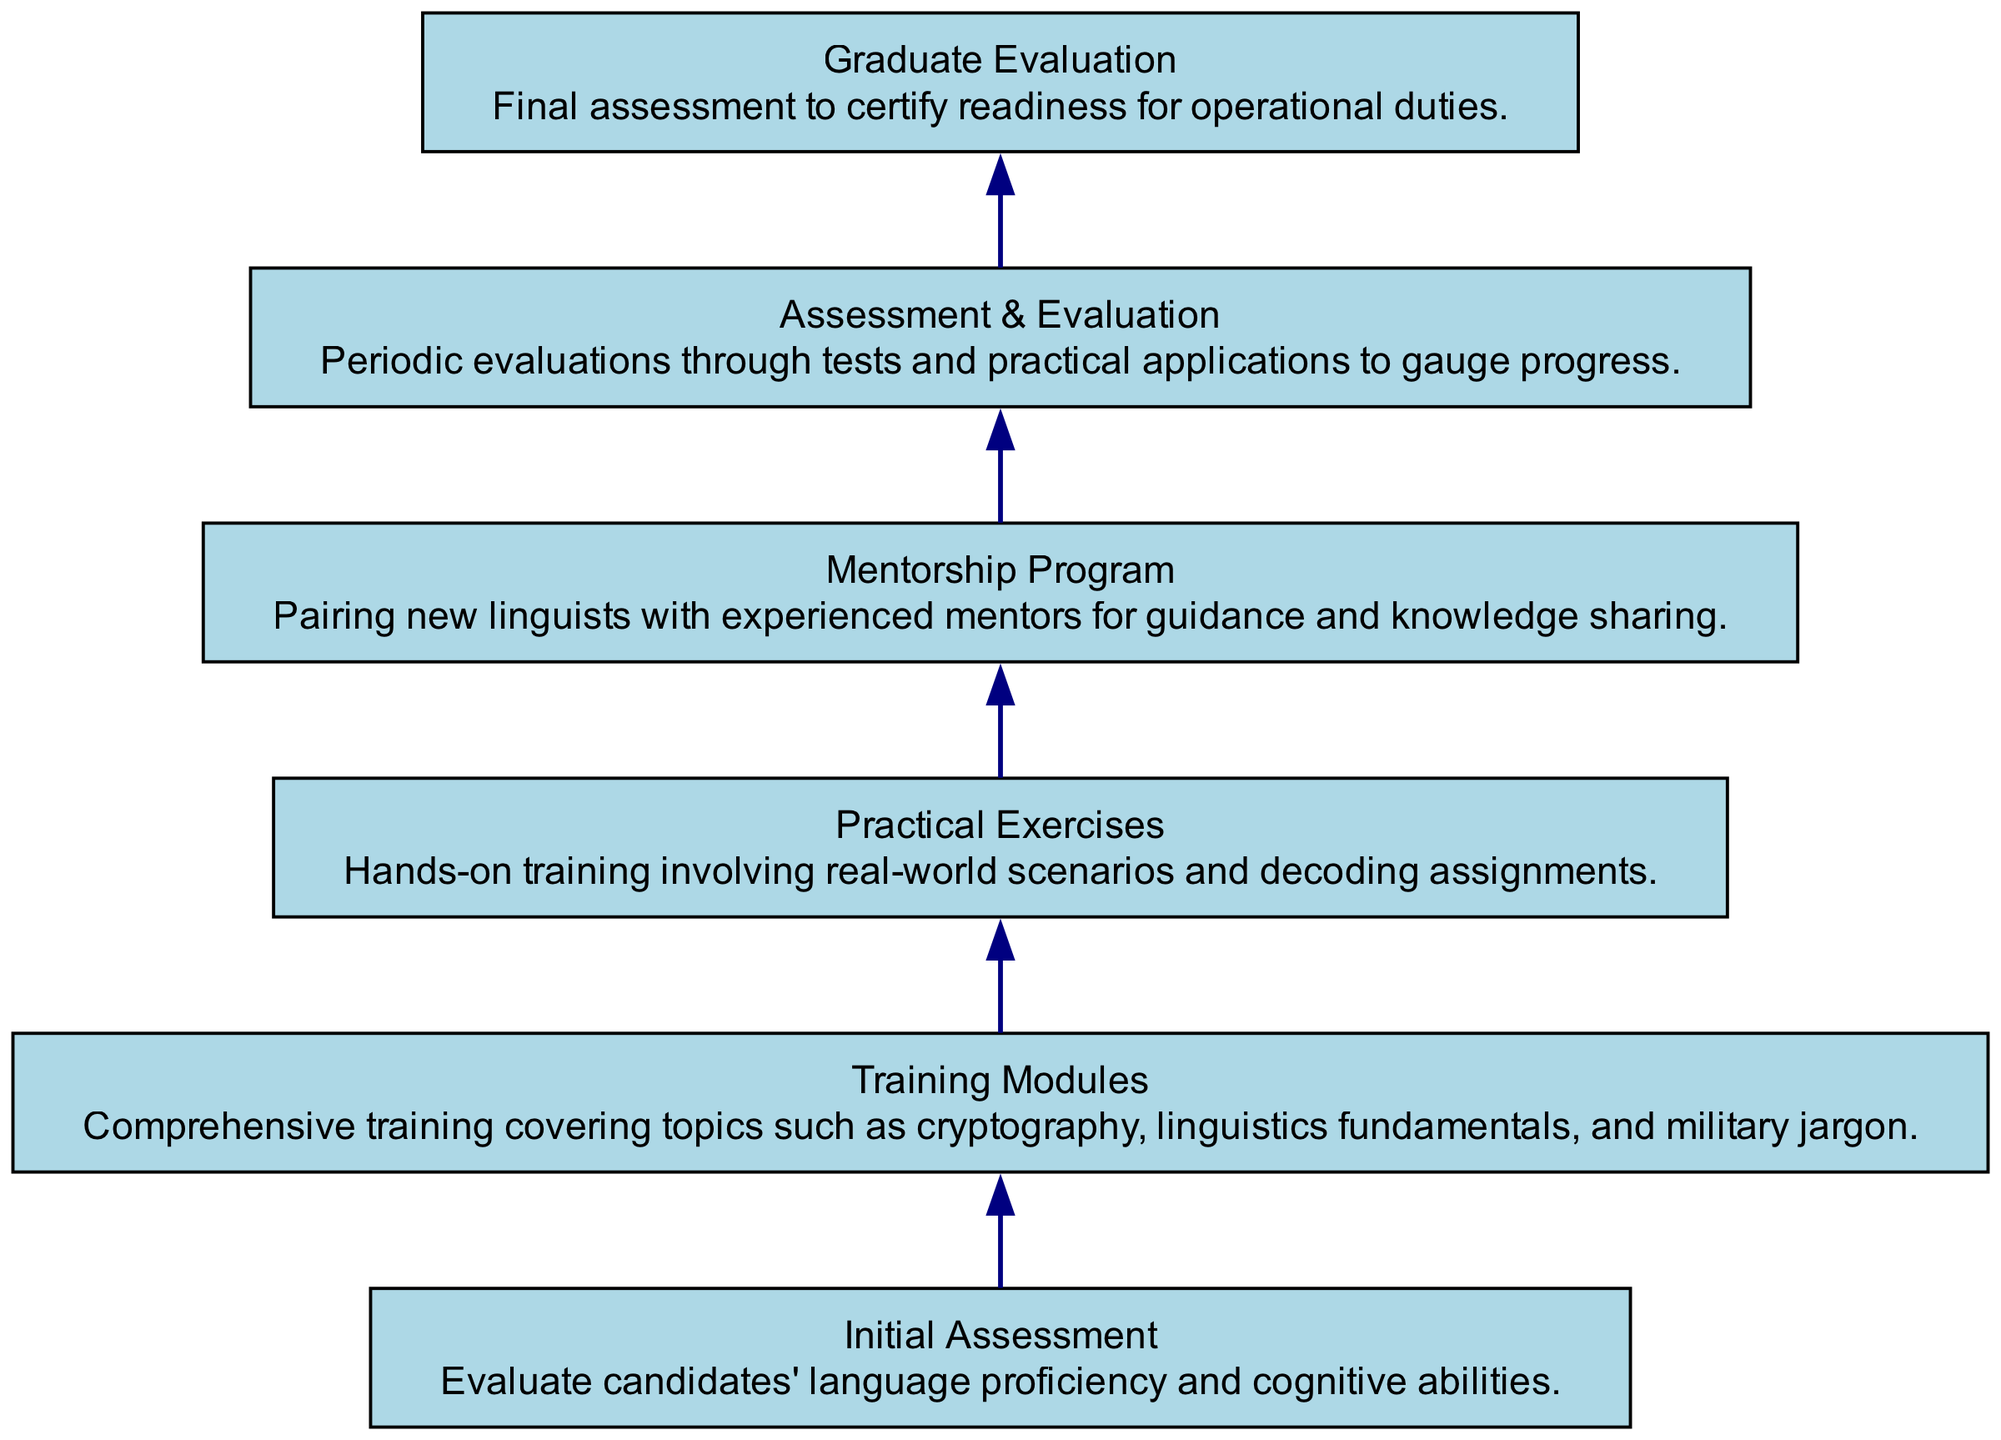What is the first step in the training workflow? The first step in the training workflow is the "Initial Assessment," which evaluates candidates' language proficiency and cognitive abilities.
Answer: Initial Assessment How many training modules are depicted in the diagram? The diagram contains one training module labeled "Training Modules," which covers various topics relevant to new linguists.
Answer: One What follows the "Practical Exercises" in the workflow? After "Practical Exercises," the next step is the "Mentorship Program," which pairs new linguists with experienced mentors.
Answer: Mentorship Program What is the final evaluation stage of the training process? The final evaluation stage is called "Graduate Evaluation," which certifies the readiness of new linguists for operational duties.
Answer: Graduate Evaluation How many edges connect the nodes in the diagram? The diagram has five edges connecting the various nodes, depicting the flow of the training sessions.
Answer: Five Which node is immediately before the "Assessment & Evaluation"? The node immediately preceding "Assessment & Evaluation" is "Mentorship Program," showing the workflow where mentorship leads to assessment.
Answer: Mentorship Program What role does the "Assessment & Evaluation" play in the training process? "Assessment & Evaluation" serves as a periodic checkpoint to gauge the progress of the new linguists through tests and practical applications.
Answer: Progress check What do the edges in this diagram represent? The edges represent the flow of the training workflow, showing the sequential progression from one stage to the next in the training process.
Answer: Sequential flow Which component connects the "Training Modules" to "Practical Exercises"? The component that connects "Training Modules" to "Practical Exercises" is an edge that signifies the transition from theoretical training to hands-on practice.
Answer: Edge 